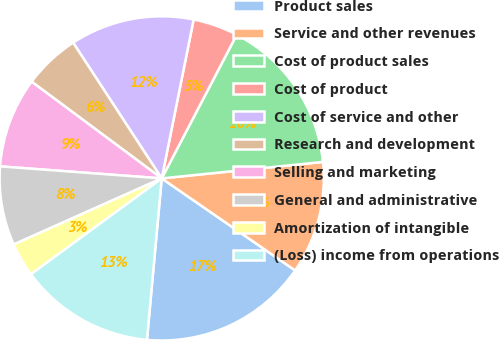Convert chart. <chart><loc_0><loc_0><loc_500><loc_500><pie_chart><fcel>Product sales<fcel>Service and other revenues<fcel>Cost of product sales<fcel>Cost of product<fcel>Cost of service and other<fcel>Research and development<fcel>Selling and marketing<fcel>General and administrative<fcel>Amortization of intangible<fcel>(Loss) income from operations<nl><fcel>16.84%<fcel>11.23%<fcel>15.72%<fcel>4.5%<fcel>12.36%<fcel>5.62%<fcel>8.99%<fcel>7.87%<fcel>3.38%<fcel>13.48%<nl></chart> 